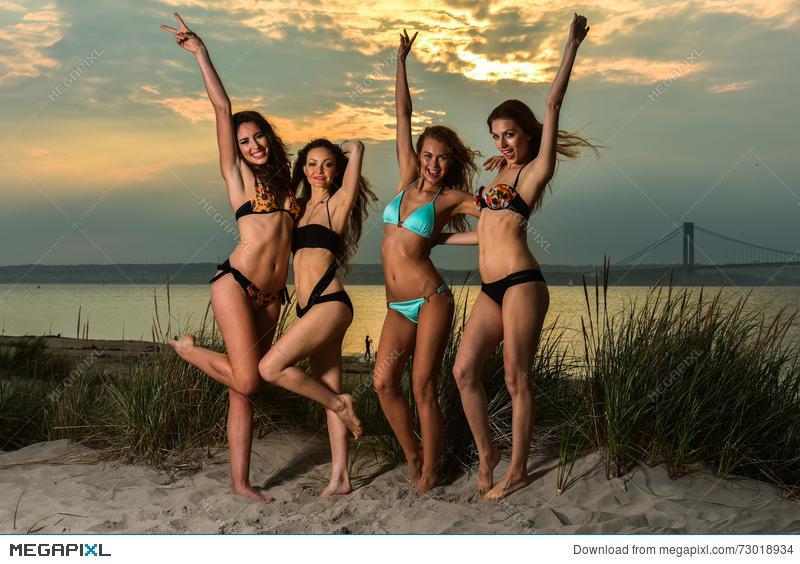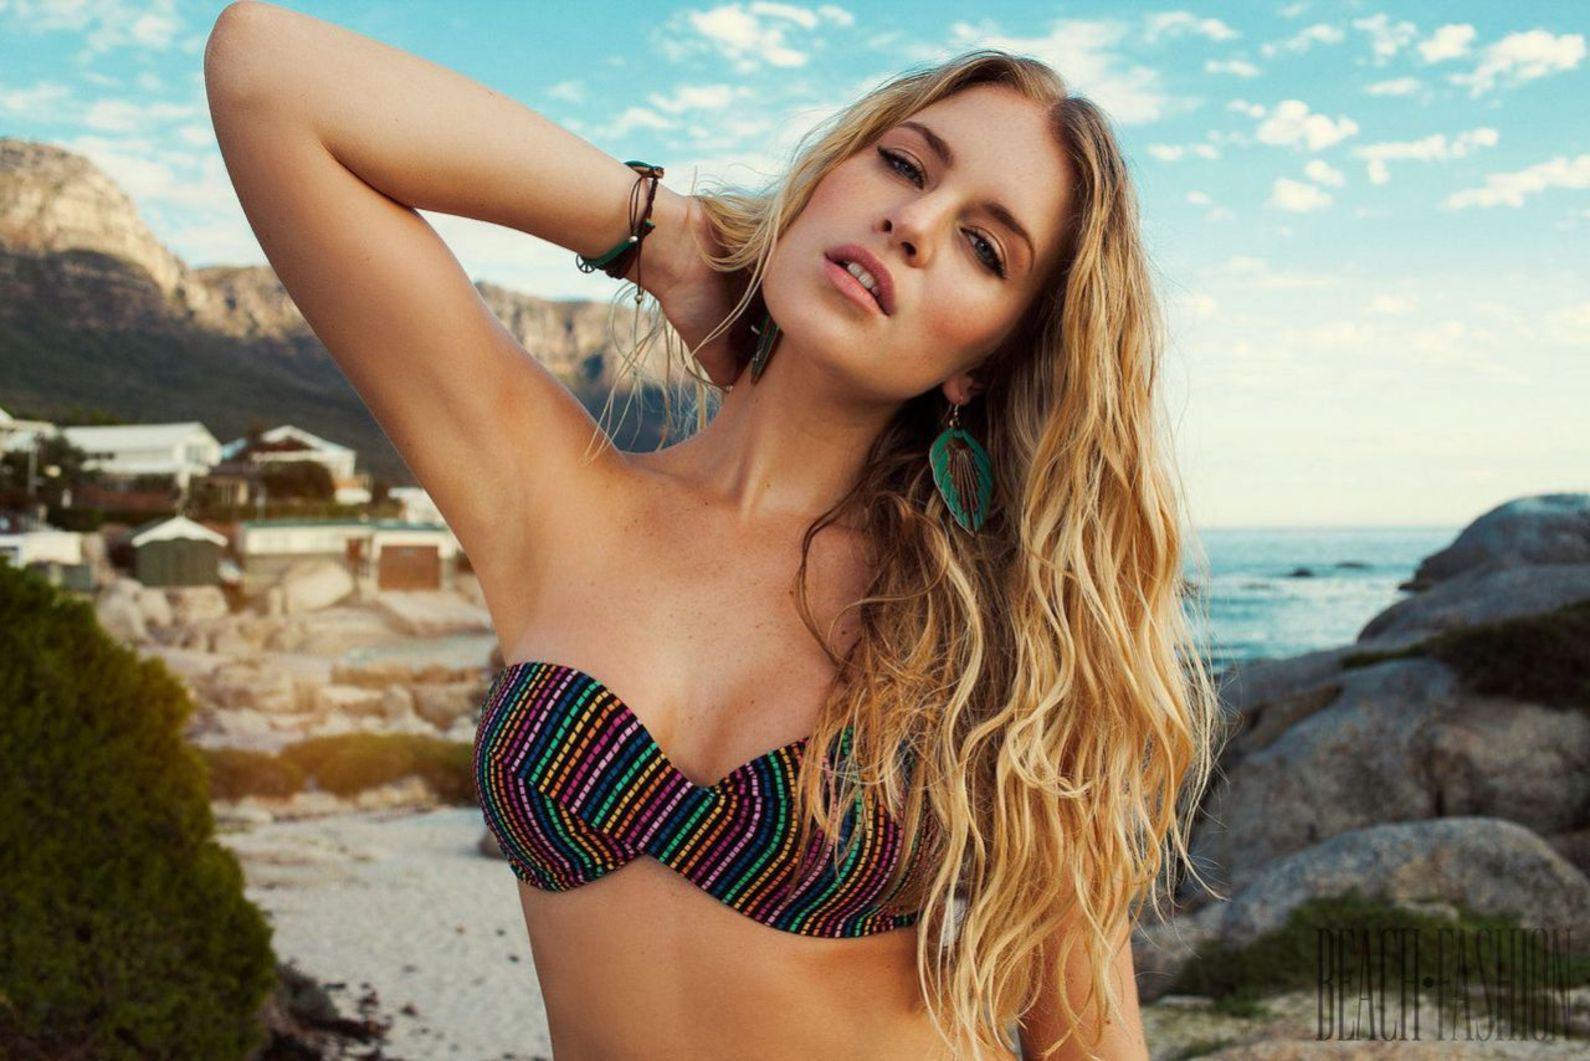The first image is the image on the left, the second image is the image on the right. Assess this claim about the two images: "There are exactly two women.". Correct or not? Answer yes or no. No. The first image is the image on the left, the second image is the image on the right. Examine the images to the left and right. Is the description "The right image shows one blonde model in a printed bikini with the arm on the left raised to her head and boulders behind her." accurate? Answer yes or no. Yes. 